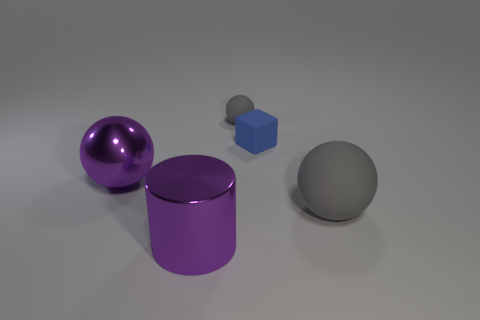There is a large gray object that is the same shape as the tiny gray thing; what material is it?
Ensure brevity in your answer.  Rubber. Are there any other things of the same color as the shiny cylinder?
Keep it short and to the point. Yes. There is a object that is the same color as the big shiny cylinder; what shape is it?
Keep it short and to the point. Sphere. There is a sphere that is behind the purple sphere; what is its size?
Your answer should be compact. Small. What shape is the purple thing that is the same size as the purple ball?
Offer a terse response. Cylinder. Are the gray thing that is in front of the matte cube and the gray thing that is behind the purple metal sphere made of the same material?
Your answer should be compact. Yes. What material is the gray ball that is to the left of the gray matte thing that is in front of the blue object?
Your answer should be compact. Rubber. There is a purple metallic object that is in front of the large metallic thing on the left side of the big purple thing to the right of the purple shiny ball; how big is it?
Your answer should be compact. Large. Do the purple metal ball and the blue rubber block have the same size?
Offer a very short reply. No. There is a metallic object that is behind the big metallic cylinder; is it the same shape as the large gray rubber thing that is in front of the tiny gray sphere?
Your answer should be very brief. Yes. 